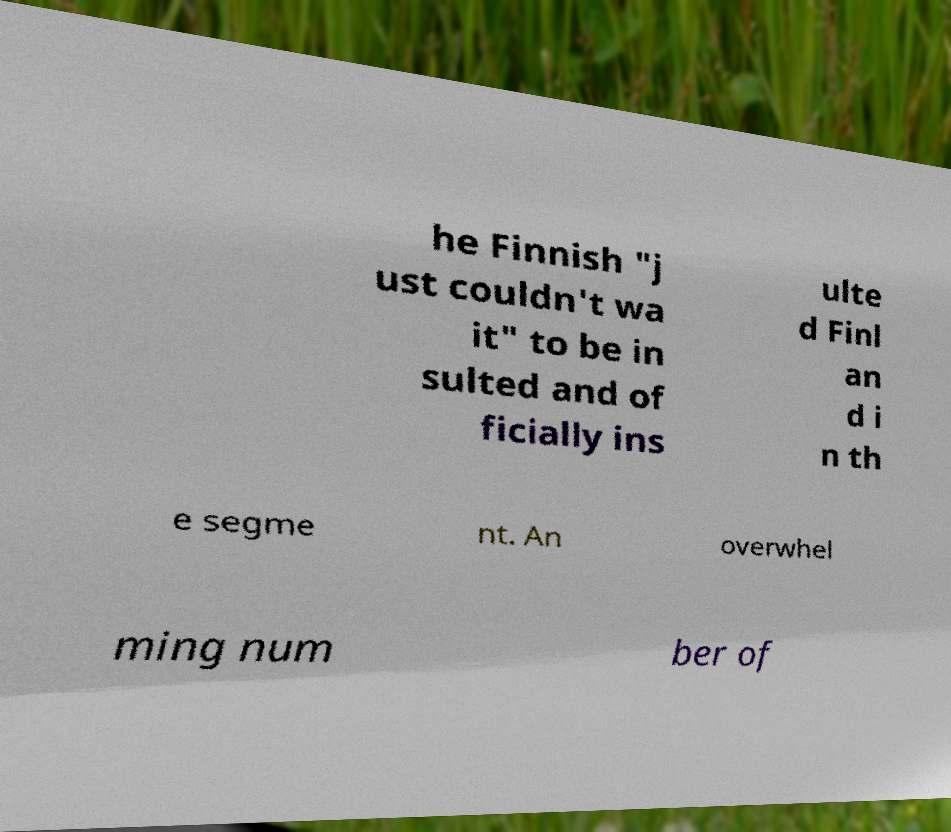Could you assist in decoding the text presented in this image and type it out clearly? he Finnish "j ust couldn't wa it" to be in sulted and of ficially ins ulte d Finl an d i n th e segme nt. An overwhel ming num ber of 